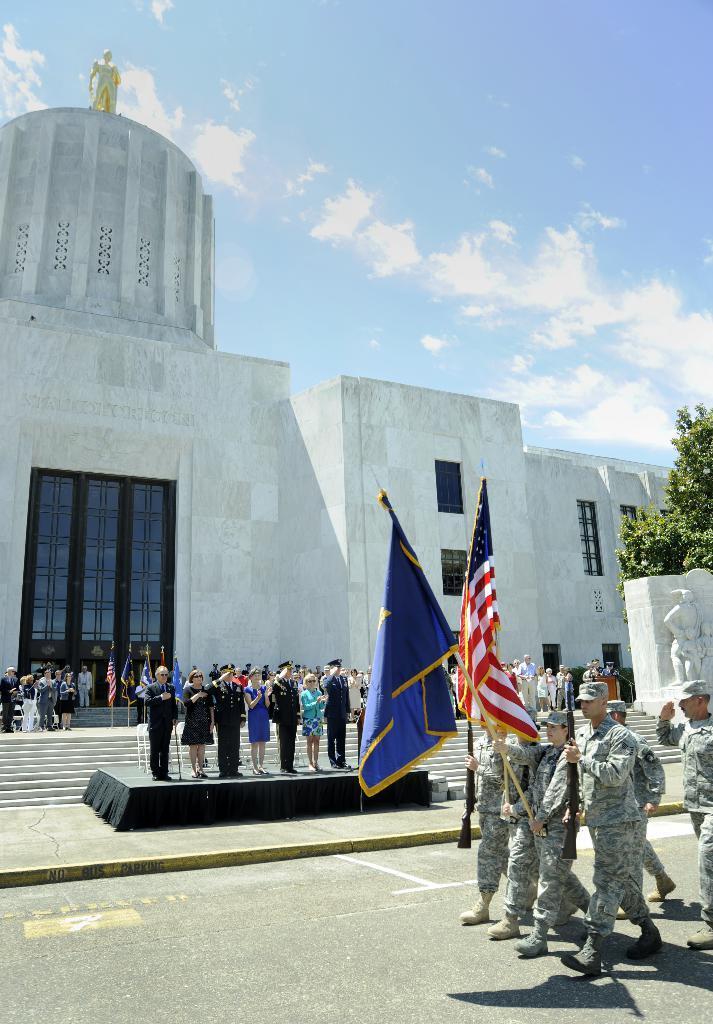Can you describe this image briefly? At the bottom of the image, we can see people, flags, stairs, stage, walkway and road. On the right side of the image, we can see people are walking on the road. Few people are holding some objects. Here there is a tree and statue. Background there is a building, wall, windows, door and sky. On top of the building, there is a statue. 